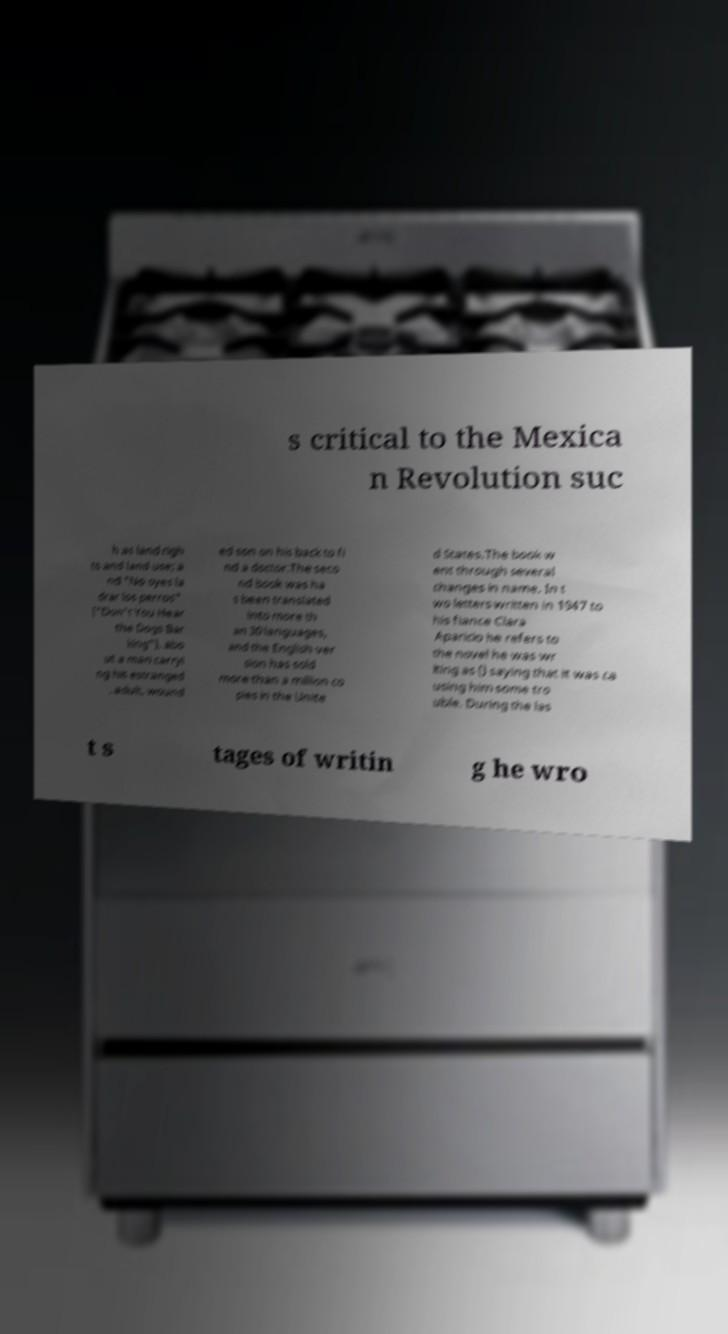There's text embedded in this image that I need extracted. Can you transcribe it verbatim? s critical to the Mexica n Revolution suc h as land righ ts and land use; a nd "No oyes la drar los perros" ("Don't You Hear the Dogs Bar king"), abo ut a man carryi ng his estranged , adult, wound ed son on his back to fi nd a doctor.The seco nd book was ha s been translated into more th an 30 languages, and the English ver sion has sold more than a million co pies in the Unite d States.The book w ent through several changes in name. In t wo letters written in 1947 to his fiance Clara Aparicio he refers to the novel he was wr iting as () saying that it was ca using him some tro uble. During the las t s tages of writin g he wro 